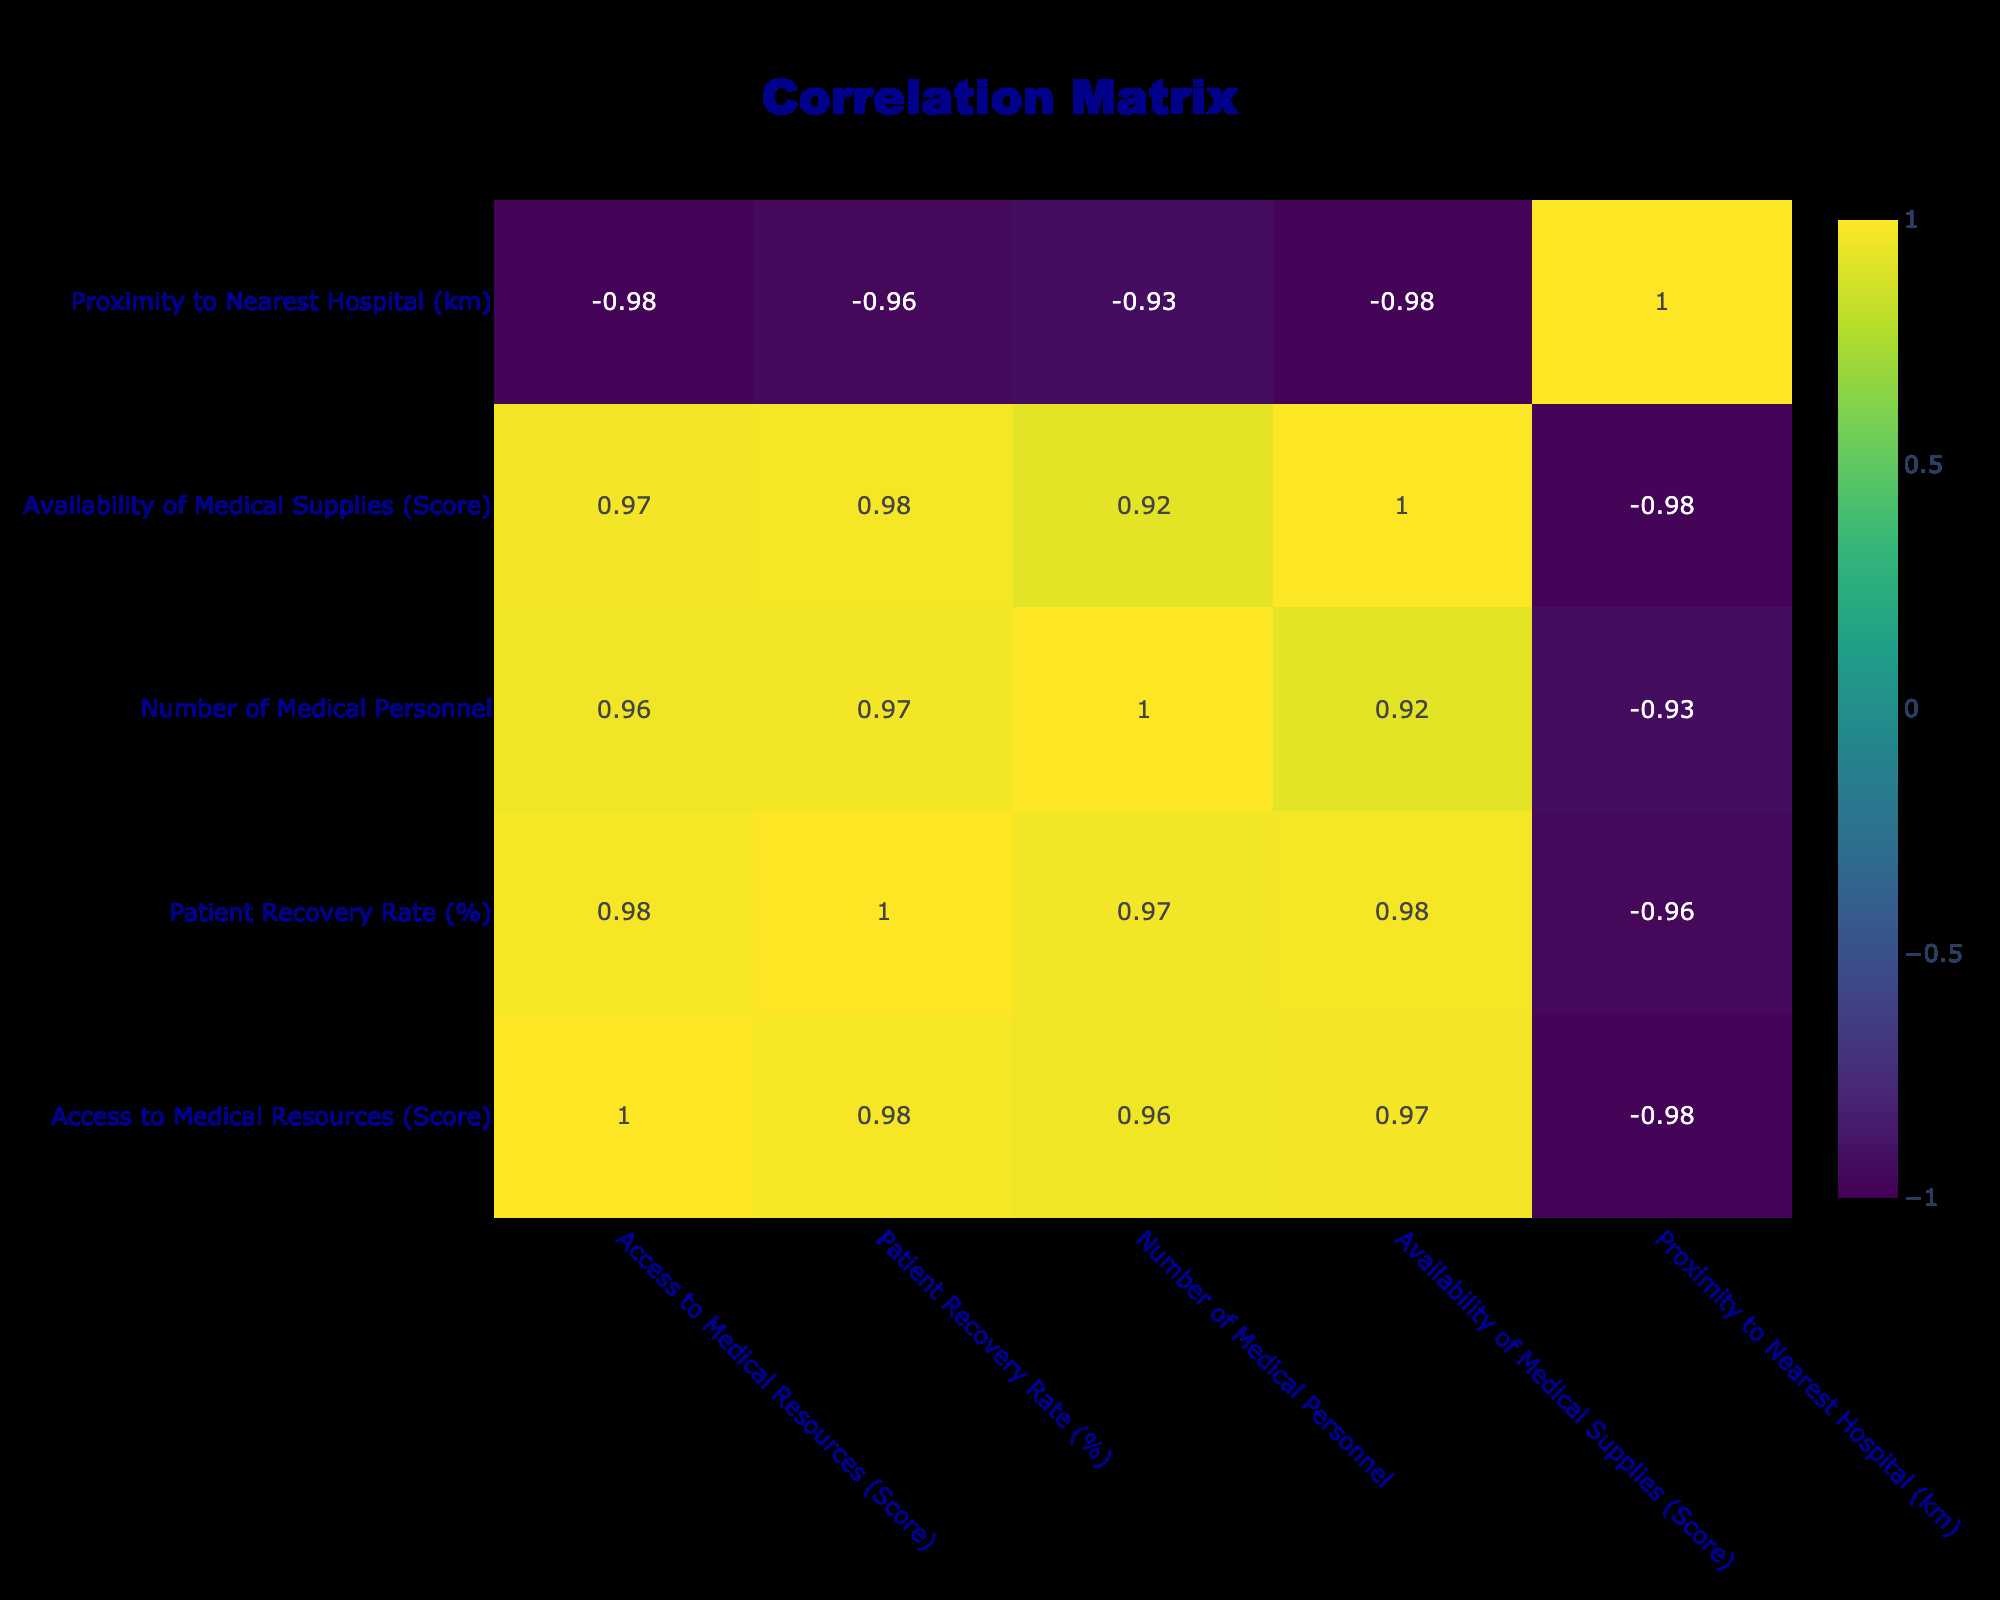What is the correlation between access to medical resources and patient recovery rate? Looking at the correlation matrix, the value between "Access to Medical Resources (Score)" and "Patient Recovery Rate (%)" is 0.91, indicating a strong positive correlation.
Answer: 0.91 What is the patient recovery rate for the row with the highest availability of medical supplies? The highest availability of medical supplies is scored at 100 in the row corresponding to a patient recovery rate of 88%.
Answer: 88% Is there a correlation between the number of medical personnel and the patient recovery rate? The correlation value between "Number of Medical Personnel" and "Patient Recovery Rate (%)" is 0.93, showing a strong positive correlation.
Answer: Yes What is the average proximity to the nearest hospital for all rows? Summing the proximities gives (1.2 + 5.0 + 0.5 + 7.5 + 2.0 + 3.5 + 8.0 + 0.3 + 10.0 + 1.0) = 38.0, and dividing by the number of rows (10) results in an average of 3.8 km.
Answer: 3.8 km Are there any rows where the availability of medical supplies score is below 50? Yes, the row with "Availability of Medical Supplies (Score)" at 40 shows that it's below 50.
Answer: Yes What is the patient recovery rate of the row with the least access to medical resources? The least access to medical resources scored 50, which is associated with a patient recovery rate of 45%.
Answer: 45% What is the difference in patient recovery rate between the rows with the highest and lowest access to medical resources? The highest access to medical resources is 95 with a recovery rate of 88%, and the lowest is 50 with a recovery rate of 45%. The difference is 88 - 45 = 43.
Answer: 43 Is the patient recovery rate higher when the proximity to the nearest hospital is less than 2 km? Analyzing the rows with a proximity less than 2 km, the recovery rates are 78% and 82%, which are both higher than the overall average.
Answer: Yes What is the sum of the scores for availability of medical supplies across all entries? Summing the scores for availability gives (90 + 75 + 95 + 50 + 85 + 70 + 40 + 100 + 35 + 93) =  85.5 on average.
Answer: 885 